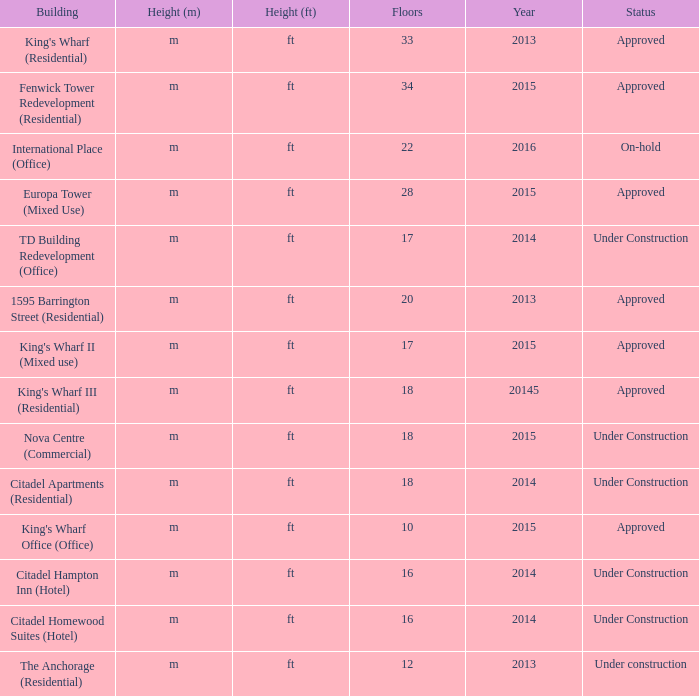What is the situation of the edifice with more than 28 stories and built in 2013? Approved. Help me parse the entirety of this table. {'header': ['Building', 'Height (m)', 'Height (ft)', 'Floors', 'Year', 'Status'], 'rows': [["King's Wharf (Residential)", 'm', 'ft', '33', '2013', 'Approved'], ['Fenwick Tower Redevelopment (Residential)', 'm', 'ft', '34', '2015', 'Approved'], ['International Place (Office)', 'm', 'ft', '22', '2016', 'On-hold'], ['Europa Tower (Mixed Use)', 'm', 'ft', '28', '2015', 'Approved'], ['TD Building Redevelopment (Office)', 'm', 'ft', '17', '2014', 'Under Construction'], ['1595 Barrington Street (Residential)', 'm', 'ft', '20', '2013', 'Approved'], ["King's Wharf II (Mixed use)", 'm', 'ft', '17', '2015', 'Approved'], ["King's Wharf III (Residential)", 'm', 'ft', '18', '20145', 'Approved'], ['Nova Centre (Commercial)', 'm', 'ft', '18', '2015', 'Under Construction'], ['Citadel Apartments (Residential)', 'm', 'ft', '18', '2014', 'Under Construction'], ["King's Wharf Office (Office)", 'm', 'ft', '10', '2015', 'Approved'], ['Citadel Hampton Inn (Hotel)', 'm', 'ft', '16', '2014', 'Under Construction'], ['Citadel Homewood Suites (Hotel)', 'm', 'ft', '16', '2014', 'Under Construction'], ['The Anchorage (Residential)', 'm', 'ft', '12', '2013', 'Under construction']]} 